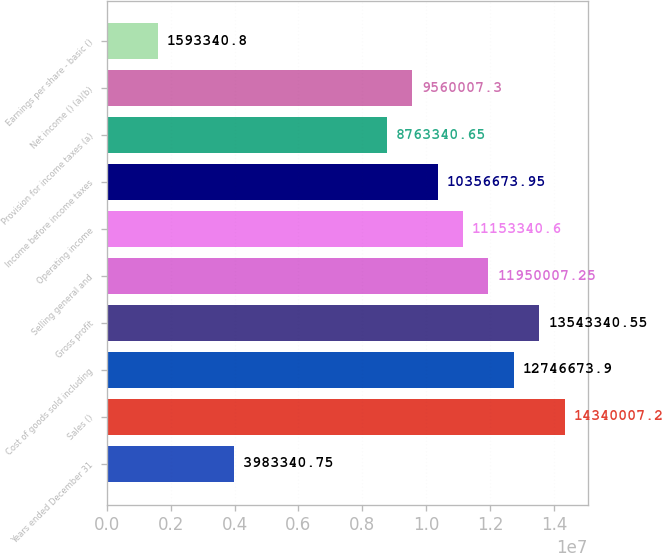Convert chart to OTSL. <chart><loc_0><loc_0><loc_500><loc_500><bar_chart><fcel>Years ended December 31<fcel>Sales ()<fcel>Cost of goods sold including<fcel>Gross profit<fcel>Selling general and<fcel>Operating income<fcel>Income before income taxes<fcel>Provision for income taxes (a)<fcel>Net income () (a)(b)<fcel>Earnings per share - basic ()<nl><fcel>3.98334e+06<fcel>1.434e+07<fcel>1.27467e+07<fcel>1.35433e+07<fcel>1.195e+07<fcel>1.11533e+07<fcel>1.03567e+07<fcel>8.76334e+06<fcel>9.56001e+06<fcel>1.59334e+06<nl></chart> 